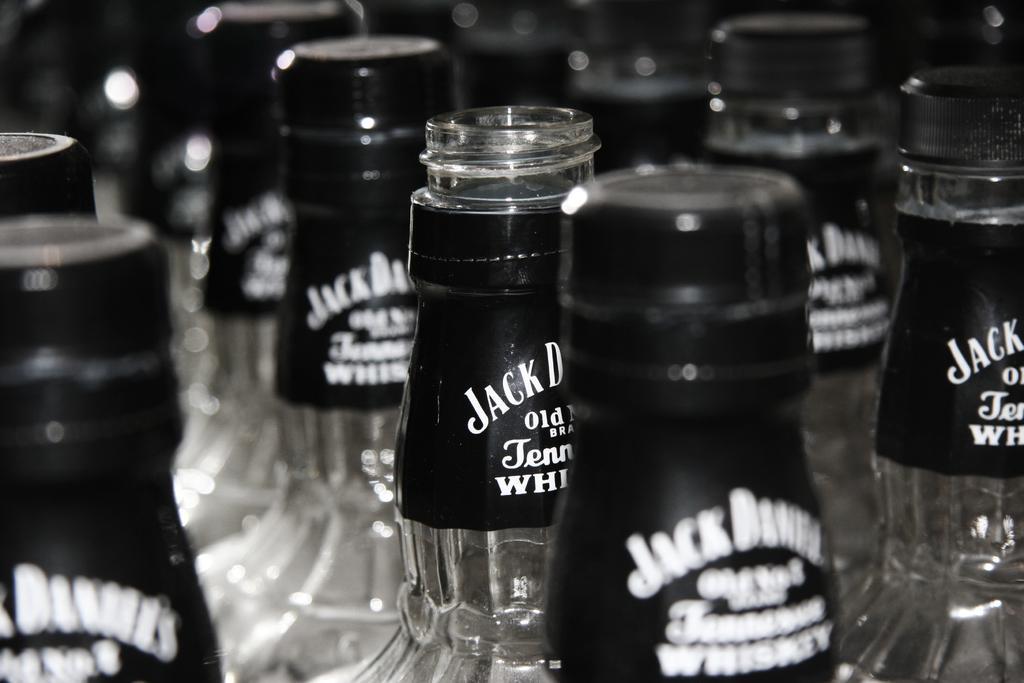Can you describe this image briefly? In this picture we can see bottles made of glass with stickers to it some cans of it are opened and some are closed. 